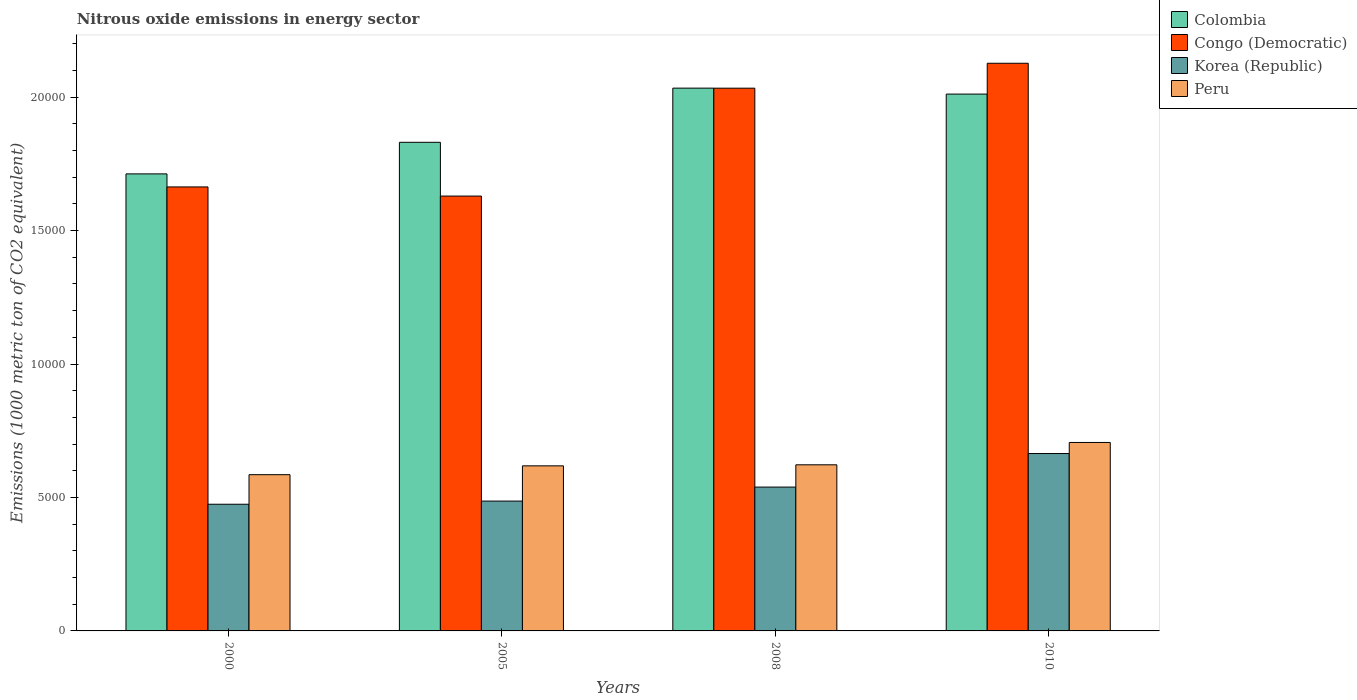How many groups of bars are there?
Provide a short and direct response. 4. Are the number of bars on each tick of the X-axis equal?
Make the answer very short. Yes. How many bars are there on the 3rd tick from the left?
Make the answer very short. 4. What is the label of the 1st group of bars from the left?
Your answer should be compact. 2000. What is the amount of nitrous oxide emitted in Peru in 2000?
Offer a terse response. 5854.9. Across all years, what is the maximum amount of nitrous oxide emitted in Korea (Republic)?
Make the answer very short. 6647.3. Across all years, what is the minimum amount of nitrous oxide emitted in Peru?
Your answer should be very brief. 5854.9. In which year was the amount of nitrous oxide emitted in Congo (Democratic) maximum?
Give a very brief answer. 2010. In which year was the amount of nitrous oxide emitted in Congo (Democratic) minimum?
Your answer should be compact. 2005. What is the total amount of nitrous oxide emitted in Colombia in the graph?
Your answer should be very brief. 7.59e+04. What is the difference between the amount of nitrous oxide emitted in Peru in 2005 and that in 2010?
Provide a succinct answer. -876.2. What is the difference between the amount of nitrous oxide emitted in Congo (Democratic) in 2000 and the amount of nitrous oxide emitted in Korea (Republic) in 2005?
Offer a very short reply. 1.18e+04. What is the average amount of nitrous oxide emitted in Korea (Republic) per year?
Provide a succinct answer. 5412.18. In the year 2010, what is the difference between the amount of nitrous oxide emitted in Korea (Republic) and amount of nitrous oxide emitted in Colombia?
Provide a succinct answer. -1.35e+04. What is the ratio of the amount of nitrous oxide emitted in Korea (Republic) in 2000 to that in 2005?
Your answer should be compact. 0.98. What is the difference between the highest and the second highest amount of nitrous oxide emitted in Colombia?
Your answer should be compact. 223.1. What is the difference between the highest and the lowest amount of nitrous oxide emitted in Peru?
Provide a succinct answer. 1207.1. How many bars are there?
Offer a terse response. 16. Are all the bars in the graph horizontal?
Give a very brief answer. No. How many years are there in the graph?
Keep it short and to the point. 4. Are the values on the major ticks of Y-axis written in scientific E-notation?
Your answer should be very brief. No. Does the graph contain any zero values?
Make the answer very short. No. How many legend labels are there?
Your response must be concise. 4. How are the legend labels stacked?
Offer a very short reply. Vertical. What is the title of the graph?
Offer a very short reply. Nitrous oxide emissions in energy sector. What is the label or title of the X-axis?
Provide a succinct answer. Years. What is the label or title of the Y-axis?
Ensure brevity in your answer.  Emissions (1000 metric ton of CO2 equivalent). What is the Emissions (1000 metric ton of CO2 equivalent) of Colombia in 2000?
Your answer should be compact. 1.71e+04. What is the Emissions (1000 metric ton of CO2 equivalent) of Congo (Democratic) in 2000?
Your answer should be very brief. 1.66e+04. What is the Emissions (1000 metric ton of CO2 equivalent) in Korea (Republic) in 2000?
Offer a terse response. 4746.8. What is the Emissions (1000 metric ton of CO2 equivalent) in Peru in 2000?
Your answer should be compact. 5854.9. What is the Emissions (1000 metric ton of CO2 equivalent) in Colombia in 2005?
Provide a succinct answer. 1.83e+04. What is the Emissions (1000 metric ton of CO2 equivalent) of Congo (Democratic) in 2005?
Make the answer very short. 1.63e+04. What is the Emissions (1000 metric ton of CO2 equivalent) in Korea (Republic) in 2005?
Offer a terse response. 4865. What is the Emissions (1000 metric ton of CO2 equivalent) of Peru in 2005?
Your response must be concise. 6185.8. What is the Emissions (1000 metric ton of CO2 equivalent) in Colombia in 2008?
Give a very brief answer. 2.03e+04. What is the Emissions (1000 metric ton of CO2 equivalent) of Congo (Democratic) in 2008?
Your answer should be very brief. 2.03e+04. What is the Emissions (1000 metric ton of CO2 equivalent) of Korea (Republic) in 2008?
Your answer should be compact. 5389.6. What is the Emissions (1000 metric ton of CO2 equivalent) in Peru in 2008?
Keep it short and to the point. 6224.5. What is the Emissions (1000 metric ton of CO2 equivalent) of Colombia in 2010?
Your response must be concise. 2.01e+04. What is the Emissions (1000 metric ton of CO2 equivalent) of Congo (Democratic) in 2010?
Provide a short and direct response. 2.13e+04. What is the Emissions (1000 metric ton of CO2 equivalent) in Korea (Republic) in 2010?
Ensure brevity in your answer.  6647.3. What is the Emissions (1000 metric ton of CO2 equivalent) of Peru in 2010?
Your answer should be compact. 7062. Across all years, what is the maximum Emissions (1000 metric ton of CO2 equivalent) in Colombia?
Make the answer very short. 2.03e+04. Across all years, what is the maximum Emissions (1000 metric ton of CO2 equivalent) of Congo (Democratic)?
Your response must be concise. 2.13e+04. Across all years, what is the maximum Emissions (1000 metric ton of CO2 equivalent) of Korea (Republic)?
Ensure brevity in your answer.  6647.3. Across all years, what is the maximum Emissions (1000 metric ton of CO2 equivalent) in Peru?
Make the answer very short. 7062. Across all years, what is the minimum Emissions (1000 metric ton of CO2 equivalent) of Colombia?
Keep it short and to the point. 1.71e+04. Across all years, what is the minimum Emissions (1000 metric ton of CO2 equivalent) of Congo (Democratic)?
Offer a terse response. 1.63e+04. Across all years, what is the minimum Emissions (1000 metric ton of CO2 equivalent) of Korea (Republic)?
Your response must be concise. 4746.8. Across all years, what is the minimum Emissions (1000 metric ton of CO2 equivalent) in Peru?
Keep it short and to the point. 5854.9. What is the total Emissions (1000 metric ton of CO2 equivalent) in Colombia in the graph?
Offer a terse response. 7.59e+04. What is the total Emissions (1000 metric ton of CO2 equivalent) of Congo (Democratic) in the graph?
Ensure brevity in your answer.  7.45e+04. What is the total Emissions (1000 metric ton of CO2 equivalent) in Korea (Republic) in the graph?
Offer a very short reply. 2.16e+04. What is the total Emissions (1000 metric ton of CO2 equivalent) of Peru in the graph?
Offer a very short reply. 2.53e+04. What is the difference between the Emissions (1000 metric ton of CO2 equivalent) of Colombia in 2000 and that in 2005?
Give a very brief answer. -1183.2. What is the difference between the Emissions (1000 metric ton of CO2 equivalent) in Congo (Democratic) in 2000 and that in 2005?
Give a very brief answer. 342.2. What is the difference between the Emissions (1000 metric ton of CO2 equivalent) of Korea (Republic) in 2000 and that in 2005?
Offer a terse response. -118.2. What is the difference between the Emissions (1000 metric ton of CO2 equivalent) of Peru in 2000 and that in 2005?
Offer a terse response. -330.9. What is the difference between the Emissions (1000 metric ton of CO2 equivalent) in Colombia in 2000 and that in 2008?
Your answer should be compact. -3213.1. What is the difference between the Emissions (1000 metric ton of CO2 equivalent) of Congo (Democratic) in 2000 and that in 2008?
Your answer should be very brief. -3700.5. What is the difference between the Emissions (1000 metric ton of CO2 equivalent) in Korea (Republic) in 2000 and that in 2008?
Your answer should be very brief. -642.8. What is the difference between the Emissions (1000 metric ton of CO2 equivalent) of Peru in 2000 and that in 2008?
Ensure brevity in your answer.  -369.6. What is the difference between the Emissions (1000 metric ton of CO2 equivalent) of Colombia in 2000 and that in 2010?
Provide a succinct answer. -2990. What is the difference between the Emissions (1000 metric ton of CO2 equivalent) of Congo (Democratic) in 2000 and that in 2010?
Provide a short and direct response. -4634.4. What is the difference between the Emissions (1000 metric ton of CO2 equivalent) in Korea (Republic) in 2000 and that in 2010?
Offer a very short reply. -1900.5. What is the difference between the Emissions (1000 metric ton of CO2 equivalent) in Peru in 2000 and that in 2010?
Keep it short and to the point. -1207.1. What is the difference between the Emissions (1000 metric ton of CO2 equivalent) in Colombia in 2005 and that in 2008?
Your response must be concise. -2029.9. What is the difference between the Emissions (1000 metric ton of CO2 equivalent) in Congo (Democratic) in 2005 and that in 2008?
Make the answer very short. -4042.7. What is the difference between the Emissions (1000 metric ton of CO2 equivalent) of Korea (Republic) in 2005 and that in 2008?
Keep it short and to the point. -524.6. What is the difference between the Emissions (1000 metric ton of CO2 equivalent) in Peru in 2005 and that in 2008?
Provide a short and direct response. -38.7. What is the difference between the Emissions (1000 metric ton of CO2 equivalent) of Colombia in 2005 and that in 2010?
Provide a succinct answer. -1806.8. What is the difference between the Emissions (1000 metric ton of CO2 equivalent) of Congo (Democratic) in 2005 and that in 2010?
Make the answer very short. -4976.6. What is the difference between the Emissions (1000 metric ton of CO2 equivalent) of Korea (Republic) in 2005 and that in 2010?
Offer a terse response. -1782.3. What is the difference between the Emissions (1000 metric ton of CO2 equivalent) in Peru in 2005 and that in 2010?
Offer a terse response. -876.2. What is the difference between the Emissions (1000 metric ton of CO2 equivalent) of Colombia in 2008 and that in 2010?
Your answer should be very brief. 223.1. What is the difference between the Emissions (1000 metric ton of CO2 equivalent) of Congo (Democratic) in 2008 and that in 2010?
Give a very brief answer. -933.9. What is the difference between the Emissions (1000 metric ton of CO2 equivalent) in Korea (Republic) in 2008 and that in 2010?
Offer a terse response. -1257.7. What is the difference between the Emissions (1000 metric ton of CO2 equivalent) of Peru in 2008 and that in 2010?
Your answer should be very brief. -837.5. What is the difference between the Emissions (1000 metric ton of CO2 equivalent) in Colombia in 2000 and the Emissions (1000 metric ton of CO2 equivalent) in Congo (Democratic) in 2005?
Offer a terse response. 831.5. What is the difference between the Emissions (1000 metric ton of CO2 equivalent) of Colombia in 2000 and the Emissions (1000 metric ton of CO2 equivalent) of Korea (Republic) in 2005?
Provide a succinct answer. 1.23e+04. What is the difference between the Emissions (1000 metric ton of CO2 equivalent) in Colombia in 2000 and the Emissions (1000 metric ton of CO2 equivalent) in Peru in 2005?
Offer a terse response. 1.09e+04. What is the difference between the Emissions (1000 metric ton of CO2 equivalent) of Congo (Democratic) in 2000 and the Emissions (1000 metric ton of CO2 equivalent) of Korea (Republic) in 2005?
Offer a terse response. 1.18e+04. What is the difference between the Emissions (1000 metric ton of CO2 equivalent) of Congo (Democratic) in 2000 and the Emissions (1000 metric ton of CO2 equivalent) of Peru in 2005?
Provide a short and direct response. 1.05e+04. What is the difference between the Emissions (1000 metric ton of CO2 equivalent) in Korea (Republic) in 2000 and the Emissions (1000 metric ton of CO2 equivalent) in Peru in 2005?
Your answer should be compact. -1439. What is the difference between the Emissions (1000 metric ton of CO2 equivalent) of Colombia in 2000 and the Emissions (1000 metric ton of CO2 equivalent) of Congo (Democratic) in 2008?
Provide a short and direct response. -3211.2. What is the difference between the Emissions (1000 metric ton of CO2 equivalent) in Colombia in 2000 and the Emissions (1000 metric ton of CO2 equivalent) in Korea (Republic) in 2008?
Offer a very short reply. 1.17e+04. What is the difference between the Emissions (1000 metric ton of CO2 equivalent) in Colombia in 2000 and the Emissions (1000 metric ton of CO2 equivalent) in Peru in 2008?
Your answer should be compact. 1.09e+04. What is the difference between the Emissions (1000 metric ton of CO2 equivalent) of Congo (Democratic) in 2000 and the Emissions (1000 metric ton of CO2 equivalent) of Korea (Republic) in 2008?
Keep it short and to the point. 1.12e+04. What is the difference between the Emissions (1000 metric ton of CO2 equivalent) in Congo (Democratic) in 2000 and the Emissions (1000 metric ton of CO2 equivalent) in Peru in 2008?
Ensure brevity in your answer.  1.04e+04. What is the difference between the Emissions (1000 metric ton of CO2 equivalent) of Korea (Republic) in 2000 and the Emissions (1000 metric ton of CO2 equivalent) of Peru in 2008?
Offer a very short reply. -1477.7. What is the difference between the Emissions (1000 metric ton of CO2 equivalent) of Colombia in 2000 and the Emissions (1000 metric ton of CO2 equivalent) of Congo (Democratic) in 2010?
Make the answer very short. -4145.1. What is the difference between the Emissions (1000 metric ton of CO2 equivalent) of Colombia in 2000 and the Emissions (1000 metric ton of CO2 equivalent) of Korea (Republic) in 2010?
Offer a very short reply. 1.05e+04. What is the difference between the Emissions (1000 metric ton of CO2 equivalent) in Colombia in 2000 and the Emissions (1000 metric ton of CO2 equivalent) in Peru in 2010?
Your answer should be compact. 1.01e+04. What is the difference between the Emissions (1000 metric ton of CO2 equivalent) in Congo (Democratic) in 2000 and the Emissions (1000 metric ton of CO2 equivalent) in Korea (Republic) in 2010?
Your answer should be compact. 9989.9. What is the difference between the Emissions (1000 metric ton of CO2 equivalent) in Congo (Democratic) in 2000 and the Emissions (1000 metric ton of CO2 equivalent) in Peru in 2010?
Provide a short and direct response. 9575.2. What is the difference between the Emissions (1000 metric ton of CO2 equivalent) in Korea (Republic) in 2000 and the Emissions (1000 metric ton of CO2 equivalent) in Peru in 2010?
Offer a very short reply. -2315.2. What is the difference between the Emissions (1000 metric ton of CO2 equivalent) in Colombia in 2005 and the Emissions (1000 metric ton of CO2 equivalent) in Congo (Democratic) in 2008?
Your answer should be compact. -2028. What is the difference between the Emissions (1000 metric ton of CO2 equivalent) of Colombia in 2005 and the Emissions (1000 metric ton of CO2 equivalent) of Korea (Republic) in 2008?
Make the answer very short. 1.29e+04. What is the difference between the Emissions (1000 metric ton of CO2 equivalent) of Colombia in 2005 and the Emissions (1000 metric ton of CO2 equivalent) of Peru in 2008?
Your response must be concise. 1.21e+04. What is the difference between the Emissions (1000 metric ton of CO2 equivalent) in Congo (Democratic) in 2005 and the Emissions (1000 metric ton of CO2 equivalent) in Korea (Republic) in 2008?
Your answer should be compact. 1.09e+04. What is the difference between the Emissions (1000 metric ton of CO2 equivalent) in Congo (Democratic) in 2005 and the Emissions (1000 metric ton of CO2 equivalent) in Peru in 2008?
Offer a very short reply. 1.01e+04. What is the difference between the Emissions (1000 metric ton of CO2 equivalent) of Korea (Republic) in 2005 and the Emissions (1000 metric ton of CO2 equivalent) of Peru in 2008?
Ensure brevity in your answer.  -1359.5. What is the difference between the Emissions (1000 metric ton of CO2 equivalent) in Colombia in 2005 and the Emissions (1000 metric ton of CO2 equivalent) in Congo (Democratic) in 2010?
Offer a terse response. -2961.9. What is the difference between the Emissions (1000 metric ton of CO2 equivalent) in Colombia in 2005 and the Emissions (1000 metric ton of CO2 equivalent) in Korea (Republic) in 2010?
Give a very brief answer. 1.17e+04. What is the difference between the Emissions (1000 metric ton of CO2 equivalent) in Colombia in 2005 and the Emissions (1000 metric ton of CO2 equivalent) in Peru in 2010?
Your answer should be compact. 1.12e+04. What is the difference between the Emissions (1000 metric ton of CO2 equivalent) in Congo (Democratic) in 2005 and the Emissions (1000 metric ton of CO2 equivalent) in Korea (Republic) in 2010?
Give a very brief answer. 9647.7. What is the difference between the Emissions (1000 metric ton of CO2 equivalent) in Congo (Democratic) in 2005 and the Emissions (1000 metric ton of CO2 equivalent) in Peru in 2010?
Your response must be concise. 9233. What is the difference between the Emissions (1000 metric ton of CO2 equivalent) in Korea (Republic) in 2005 and the Emissions (1000 metric ton of CO2 equivalent) in Peru in 2010?
Your answer should be very brief. -2197. What is the difference between the Emissions (1000 metric ton of CO2 equivalent) in Colombia in 2008 and the Emissions (1000 metric ton of CO2 equivalent) in Congo (Democratic) in 2010?
Offer a very short reply. -932. What is the difference between the Emissions (1000 metric ton of CO2 equivalent) of Colombia in 2008 and the Emissions (1000 metric ton of CO2 equivalent) of Korea (Republic) in 2010?
Provide a succinct answer. 1.37e+04. What is the difference between the Emissions (1000 metric ton of CO2 equivalent) in Colombia in 2008 and the Emissions (1000 metric ton of CO2 equivalent) in Peru in 2010?
Provide a short and direct response. 1.33e+04. What is the difference between the Emissions (1000 metric ton of CO2 equivalent) of Congo (Democratic) in 2008 and the Emissions (1000 metric ton of CO2 equivalent) of Korea (Republic) in 2010?
Provide a succinct answer. 1.37e+04. What is the difference between the Emissions (1000 metric ton of CO2 equivalent) of Congo (Democratic) in 2008 and the Emissions (1000 metric ton of CO2 equivalent) of Peru in 2010?
Offer a very short reply. 1.33e+04. What is the difference between the Emissions (1000 metric ton of CO2 equivalent) of Korea (Republic) in 2008 and the Emissions (1000 metric ton of CO2 equivalent) of Peru in 2010?
Give a very brief answer. -1672.4. What is the average Emissions (1000 metric ton of CO2 equivalent) in Colombia per year?
Keep it short and to the point. 1.90e+04. What is the average Emissions (1000 metric ton of CO2 equivalent) in Congo (Democratic) per year?
Offer a terse response. 1.86e+04. What is the average Emissions (1000 metric ton of CO2 equivalent) in Korea (Republic) per year?
Your answer should be compact. 5412.18. What is the average Emissions (1000 metric ton of CO2 equivalent) of Peru per year?
Offer a very short reply. 6331.8. In the year 2000, what is the difference between the Emissions (1000 metric ton of CO2 equivalent) of Colombia and Emissions (1000 metric ton of CO2 equivalent) of Congo (Democratic)?
Offer a very short reply. 489.3. In the year 2000, what is the difference between the Emissions (1000 metric ton of CO2 equivalent) in Colombia and Emissions (1000 metric ton of CO2 equivalent) in Korea (Republic)?
Make the answer very short. 1.24e+04. In the year 2000, what is the difference between the Emissions (1000 metric ton of CO2 equivalent) in Colombia and Emissions (1000 metric ton of CO2 equivalent) in Peru?
Your response must be concise. 1.13e+04. In the year 2000, what is the difference between the Emissions (1000 metric ton of CO2 equivalent) in Congo (Democratic) and Emissions (1000 metric ton of CO2 equivalent) in Korea (Republic)?
Your answer should be very brief. 1.19e+04. In the year 2000, what is the difference between the Emissions (1000 metric ton of CO2 equivalent) in Congo (Democratic) and Emissions (1000 metric ton of CO2 equivalent) in Peru?
Offer a very short reply. 1.08e+04. In the year 2000, what is the difference between the Emissions (1000 metric ton of CO2 equivalent) in Korea (Republic) and Emissions (1000 metric ton of CO2 equivalent) in Peru?
Offer a terse response. -1108.1. In the year 2005, what is the difference between the Emissions (1000 metric ton of CO2 equivalent) of Colombia and Emissions (1000 metric ton of CO2 equivalent) of Congo (Democratic)?
Offer a very short reply. 2014.7. In the year 2005, what is the difference between the Emissions (1000 metric ton of CO2 equivalent) of Colombia and Emissions (1000 metric ton of CO2 equivalent) of Korea (Republic)?
Ensure brevity in your answer.  1.34e+04. In the year 2005, what is the difference between the Emissions (1000 metric ton of CO2 equivalent) of Colombia and Emissions (1000 metric ton of CO2 equivalent) of Peru?
Your answer should be compact. 1.21e+04. In the year 2005, what is the difference between the Emissions (1000 metric ton of CO2 equivalent) of Congo (Democratic) and Emissions (1000 metric ton of CO2 equivalent) of Korea (Republic)?
Make the answer very short. 1.14e+04. In the year 2005, what is the difference between the Emissions (1000 metric ton of CO2 equivalent) of Congo (Democratic) and Emissions (1000 metric ton of CO2 equivalent) of Peru?
Give a very brief answer. 1.01e+04. In the year 2005, what is the difference between the Emissions (1000 metric ton of CO2 equivalent) in Korea (Republic) and Emissions (1000 metric ton of CO2 equivalent) in Peru?
Provide a succinct answer. -1320.8. In the year 2008, what is the difference between the Emissions (1000 metric ton of CO2 equivalent) of Colombia and Emissions (1000 metric ton of CO2 equivalent) of Korea (Republic)?
Offer a very short reply. 1.50e+04. In the year 2008, what is the difference between the Emissions (1000 metric ton of CO2 equivalent) in Colombia and Emissions (1000 metric ton of CO2 equivalent) in Peru?
Offer a terse response. 1.41e+04. In the year 2008, what is the difference between the Emissions (1000 metric ton of CO2 equivalent) of Congo (Democratic) and Emissions (1000 metric ton of CO2 equivalent) of Korea (Republic)?
Give a very brief answer. 1.49e+04. In the year 2008, what is the difference between the Emissions (1000 metric ton of CO2 equivalent) in Congo (Democratic) and Emissions (1000 metric ton of CO2 equivalent) in Peru?
Offer a very short reply. 1.41e+04. In the year 2008, what is the difference between the Emissions (1000 metric ton of CO2 equivalent) in Korea (Republic) and Emissions (1000 metric ton of CO2 equivalent) in Peru?
Offer a very short reply. -834.9. In the year 2010, what is the difference between the Emissions (1000 metric ton of CO2 equivalent) of Colombia and Emissions (1000 metric ton of CO2 equivalent) of Congo (Democratic)?
Your response must be concise. -1155.1. In the year 2010, what is the difference between the Emissions (1000 metric ton of CO2 equivalent) in Colombia and Emissions (1000 metric ton of CO2 equivalent) in Korea (Republic)?
Keep it short and to the point. 1.35e+04. In the year 2010, what is the difference between the Emissions (1000 metric ton of CO2 equivalent) in Colombia and Emissions (1000 metric ton of CO2 equivalent) in Peru?
Your answer should be compact. 1.31e+04. In the year 2010, what is the difference between the Emissions (1000 metric ton of CO2 equivalent) of Congo (Democratic) and Emissions (1000 metric ton of CO2 equivalent) of Korea (Republic)?
Your answer should be very brief. 1.46e+04. In the year 2010, what is the difference between the Emissions (1000 metric ton of CO2 equivalent) in Congo (Democratic) and Emissions (1000 metric ton of CO2 equivalent) in Peru?
Provide a short and direct response. 1.42e+04. In the year 2010, what is the difference between the Emissions (1000 metric ton of CO2 equivalent) of Korea (Republic) and Emissions (1000 metric ton of CO2 equivalent) of Peru?
Offer a very short reply. -414.7. What is the ratio of the Emissions (1000 metric ton of CO2 equivalent) of Colombia in 2000 to that in 2005?
Your response must be concise. 0.94. What is the ratio of the Emissions (1000 metric ton of CO2 equivalent) in Korea (Republic) in 2000 to that in 2005?
Your response must be concise. 0.98. What is the ratio of the Emissions (1000 metric ton of CO2 equivalent) in Peru in 2000 to that in 2005?
Your response must be concise. 0.95. What is the ratio of the Emissions (1000 metric ton of CO2 equivalent) in Colombia in 2000 to that in 2008?
Provide a succinct answer. 0.84. What is the ratio of the Emissions (1000 metric ton of CO2 equivalent) of Congo (Democratic) in 2000 to that in 2008?
Keep it short and to the point. 0.82. What is the ratio of the Emissions (1000 metric ton of CO2 equivalent) in Korea (Republic) in 2000 to that in 2008?
Offer a very short reply. 0.88. What is the ratio of the Emissions (1000 metric ton of CO2 equivalent) of Peru in 2000 to that in 2008?
Make the answer very short. 0.94. What is the ratio of the Emissions (1000 metric ton of CO2 equivalent) of Colombia in 2000 to that in 2010?
Give a very brief answer. 0.85. What is the ratio of the Emissions (1000 metric ton of CO2 equivalent) in Congo (Democratic) in 2000 to that in 2010?
Give a very brief answer. 0.78. What is the ratio of the Emissions (1000 metric ton of CO2 equivalent) in Korea (Republic) in 2000 to that in 2010?
Make the answer very short. 0.71. What is the ratio of the Emissions (1000 metric ton of CO2 equivalent) in Peru in 2000 to that in 2010?
Your response must be concise. 0.83. What is the ratio of the Emissions (1000 metric ton of CO2 equivalent) of Colombia in 2005 to that in 2008?
Offer a very short reply. 0.9. What is the ratio of the Emissions (1000 metric ton of CO2 equivalent) of Congo (Democratic) in 2005 to that in 2008?
Provide a short and direct response. 0.8. What is the ratio of the Emissions (1000 metric ton of CO2 equivalent) of Korea (Republic) in 2005 to that in 2008?
Make the answer very short. 0.9. What is the ratio of the Emissions (1000 metric ton of CO2 equivalent) in Colombia in 2005 to that in 2010?
Keep it short and to the point. 0.91. What is the ratio of the Emissions (1000 metric ton of CO2 equivalent) of Congo (Democratic) in 2005 to that in 2010?
Your response must be concise. 0.77. What is the ratio of the Emissions (1000 metric ton of CO2 equivalent) in Korea (Republic) in 2005 to that in 2010?
Provide a succinct answer. 0.73. What is the ratio of the Emissions (1000 metric ton of CO2 equivalent) of Peru in 2005 to that in 2010?
Give a very brief answer. 0.88. What is the ratio of the Emissions (1000 metric ton of CO2 equivalent) in Colombia in 2008 to that in 2010?
Your response must be concise. 1.01. What is the ratio of the Emissions (1000 metric ton of CO2 equivalent) in Congo (Democratic) in 2008 to that in 2010?
Your answer should be compact. 0.96. What is the ratio of the Emissions (1000 metric ton of CO2 equivalent) of Korea (Republic) in 2008 to that in 2010?
Make the answer very short. 0.81. What is the ratio of the Emissions (1000 metric ton of CO2 equivalent) of Peru in 2008 to that in 2010?
Your answer should be compact. 0.88. What is the difference between the highest and the second highest Emissions (1000 metric ton of CO2 equivalent) in Colombia?
Keep it short and to the point. 223.1. What is the difference between the highest and the second highest Emissions (1000 metric ton of CO2 equivalent) of Congo (Democratic)?
Give a very brief answer. 933.9. What is the difference between the highest and the second highest Emissions (1000 metric ton of CO2 equivalent) of Korea (Republic)?
Ensure brevity in your answer.  1257.7. What is the difference between the highest and the second highest Emissions (1000 metric ton of CO2 equivalent) in Peru?
Your answer should be very brief. 837.5. What is the difference between the highest and the lowest Emissions (1000 metric ton of CO2 equivalent) in Colombia?
Give a very brief answer. 3213.1. What is the difference between the highest and the lowest Emissions (1000 metric ton of CO2 equivalent) in Congo (Democratic)?
Offer a terse response. 4976.6. What is the difference between the highest and the lowest Emissions (1000 metric ton of CO2 equivalent) of Korea (Republic)?
Offer a terse response. 1900.5. What is the difference between the highest and the lowest Emissions (1000 metric ton of CO2 equivalent) in Peru?
Offer a very short reply. 1207.1. 